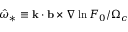<formula> <loc_0><loc_0><loc_500><loc_500>\hat { \omega } _ { * } \equiv k \cdot b \times \nabla \ln { F _ { 0 } } / \Omega _ { c }</formula> 